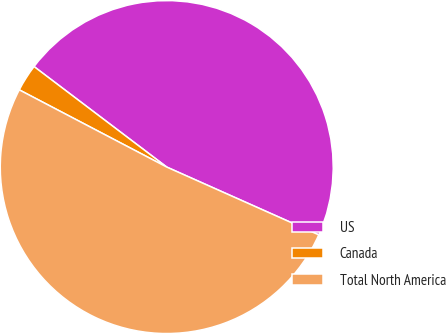<chart> <loc_0><loc_0><loc_500><loc_500><pie_chart><fcel>US<fcel>Canada<fcel>Total North America<nl><fcel>46.36%<fcel>2.64%<fcel>51.0%<nl></chart> 